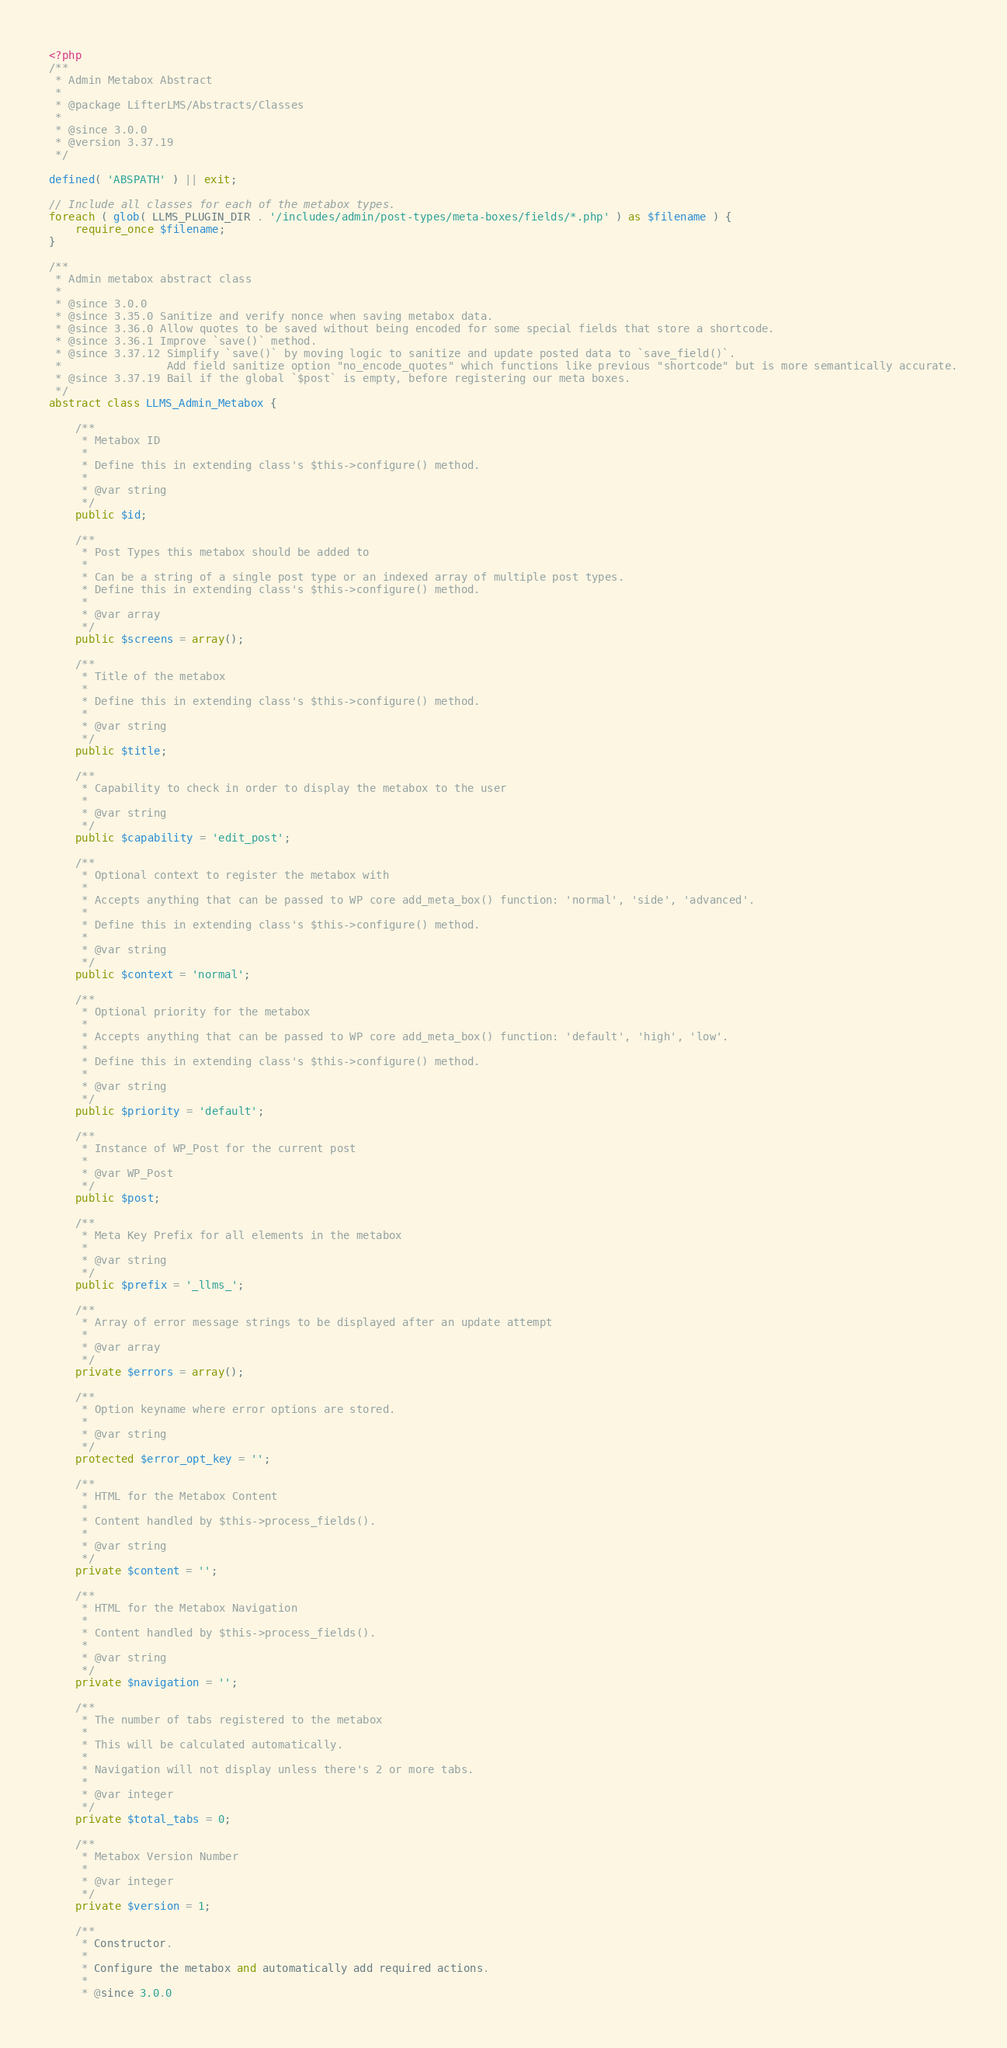<code> <loc_0><loc_0><loc_500><loc_500><_PHP_><?php
/**
 * Admin Metabox Abstract
 *
 * @package LifterLMS/Abstracts/Classes
 *
 * @since 3.0.0
 * @version 3.37.19
 */

defined( 'ABSPATH' ) || exit;

// Include all classes for each of the metabox types.
foreach ( glob( LLMS_PLUGIN_DIR . '/includes/admin/post-types/meta-boxes/fields/*.php' ) as $filename ) {
	require_once $filename;
}

/**
 * Admin metabox abstract class
 *
 * @since 3.0.0
 * @since 3.35.0 Sanitize and verify nonce when saving metabox data.
 * @since 3.36.0 Allow quotes to be saved without being encoded for some special fields that store a shortcode.
 * @since 3.36.1 Improve `save()` method.
 * @since 3.37.12 Simplify `save()` by moving logic to sanitize and update posted data to `save_field()`.
 *                Add field sanitize option "no_encode_quotes" which functions like previous "shortcode" but is more semantically accurate.
 * @since 3.37.19 Bail if the global `$post` is empty, before registering our meta boxes.
 */
abstract class LLMS_Admin_Metabox {

	/**
	 * Metabox ID
	 *
	 * Define this in extending class's $this->configure() method.
	 *
	 * @var string
	 */
	public $id;

	/**
	 * Post Types this metabox should be added to
	 *
	 * Can be a string of a single post type or an indexed array of multiple post types.
	 * Define this in extending class's $this->configure() method.
	 *
	 * @var array
	 */
	public $screens = array();

	/**
	 * Title of the metabox
	 *
	 * Define this in extending class's $this->configure() method.
	 *
	 * @var string
	 */
	public $title;

	/**
	 * Capability to check in order to display the metabox to the user
	 *
	 * @var string
	 */
	public $capability = 'edit_post';

	/**
	 * Optional context to register the metabox with
	 *
	 * Accepts anything that can be passed to WP core add_meta_box() function: 'normal', 'side', 'advanced'.
	 *
	 * Define this in extending class's $this->configure() method.
	 *
	 * @var string
	 */
	public $context = 'normal';

	/**
	 * Optional priority for the metabox
	 *
	 * Accepts anything that can be passed to WP core add_meta_box() function: 'default', 'high', 'low'.
	 *
	 * Define this in extending class's $this->configure() method.
	 *
	 * @var string
	 */
	public $priority = 'default';

	/**
	 * Instance of WP_Post for the current post
	 *
	 * @var WP_Post
	 */
	public $post;

	/**
	 * Meta Key Prefix for all elements in the metabox
	 *
	 * @var string
	 */
	public $prefix = '_llms_';

	/**
	 * Array of error message strings to be displayed after an update attempt
	 *
	 * @var array
	 */
	private $errors = array();

	/**
	 * Option keyname where error options are stored.
	 *
	 * @var string
	 */
	protected $error_opt_key = '';

	/**
	 * HTML for the Metabox Content
	 *
	 * Content handled by $this->process_fields().
	 *
	 * @var string
	 */
	private $content = '';

	/**
	 * HTML for the Metabox Navigation
	 *
	 * Content handled by $this->process_fields().
	 *
	 * @var string
	 */
	private $navigation = '';

	/**
	 * The number of tabs registered to the metabox
	 *
	 * This will be calculated automatically.
	 *
	 * Navigation will not display unless there's 2 or more tabs.
	 *
	 * @var integer
	 */
	private $total_tabs = 0;

	/**
	 * Metabox Version Number
	 *
	 * @var integer
	 */
	private $version = 1;

	/**
	 * Constructor.
	 *
	 * Configure the metabox and automatically add required actions.
	 *
	 * @since 3.0.0</code> 